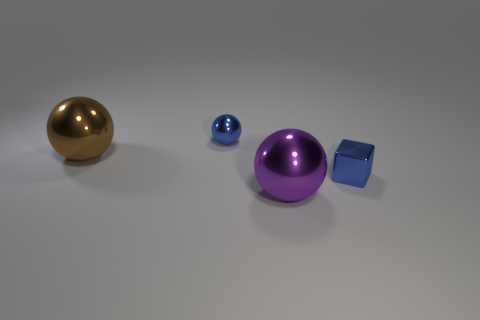Add 2 brown metal cylinders. How many objects exist? 6 Subtract all tiny balls. How many balls are left? 2 Subtract 2 spheres. How many spheres are left? 1 Subtract all blue balls. How many balls are left? 2 Subtract all cubes. How many objects are left? 3 Add 1 big purple shiny things. How many big purple shiny things are left? 2 Add 2 tiny red things. How many tiny red things exist? 2 Subtract 0 cyan spheres. How many objects are left? 4 Subtract all yellow cubes. Subtract all cyan cylinders. How many cubes are left? 1 Subtract all blue cylinders. How many purple blocks are left? 0 